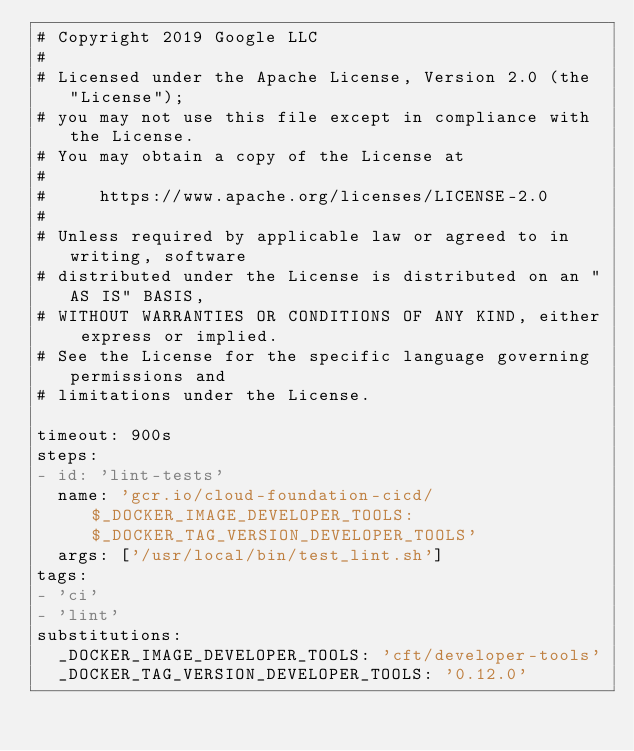Convert code to text. <code><loc_0><loc_0><loc_500><loc_500><_YAML_># Copyright 2019 Google LLC
#
# Licensed under the Apache License, Version 2.0 (the "License");
# you may not use this file except in compliance with the License.
# You may obtain a copy of the License at
#
#     https://www.apache.org/licenses/LICENSE-2.0
#
# Unless required by applicable law or agreed to in writing, software
# distributed under the License is distributed on an "AS IS" BASIS,
# WITHOUT WARRANTIES OR CONDITIONS OF ANY KIND, either express or implied.
# See the License for the specific language governing permissions and
# limitations under the License.

timeout: 900s
steps:
- id: 'lint-tests'
  name: 'gcr.io/cloud-foundation-cicd/$_DOCKER_IMAGE_DEVELOPER_TOOLS:$_DOCKER_TAG_VERSION_DEVELOPER_TOOLS'
  args: ['/usr/local/bin/test_lint.sh']
tags:
- 'ci'
- 'lint'
substitutions:
  _DOCKER_IMAGE_DEVELOPER_TOOLS: 'cft/developer-tools'
  _DOCKER_TAG_VERSION_DEVELOPER_TOOLS: '0.12.0'
</code> 